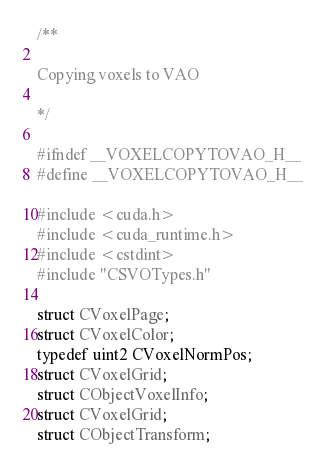Convert code to text. <code><loc_0><loc_0><loc_500><loc_500><_Cuda_>/**

Copying voxels to VAO

*/

#ifndef __VOXELCOPYTOVAO_H__
#define __VOXELCOPYTOVAO_H__

#include <cuda.h>
#include <cuda_runtime.h>
#include <cstdint>
#include "CSVOTypes.h"

struct CVoxelPage;
struct CVoxelColor;
typedef uint2 CVoxelNormPos;
struct CVoxelGrid;
struct CObjectVoxelInfo;
struct CVoxelGrid;
struct CObjectTransform;</code> 